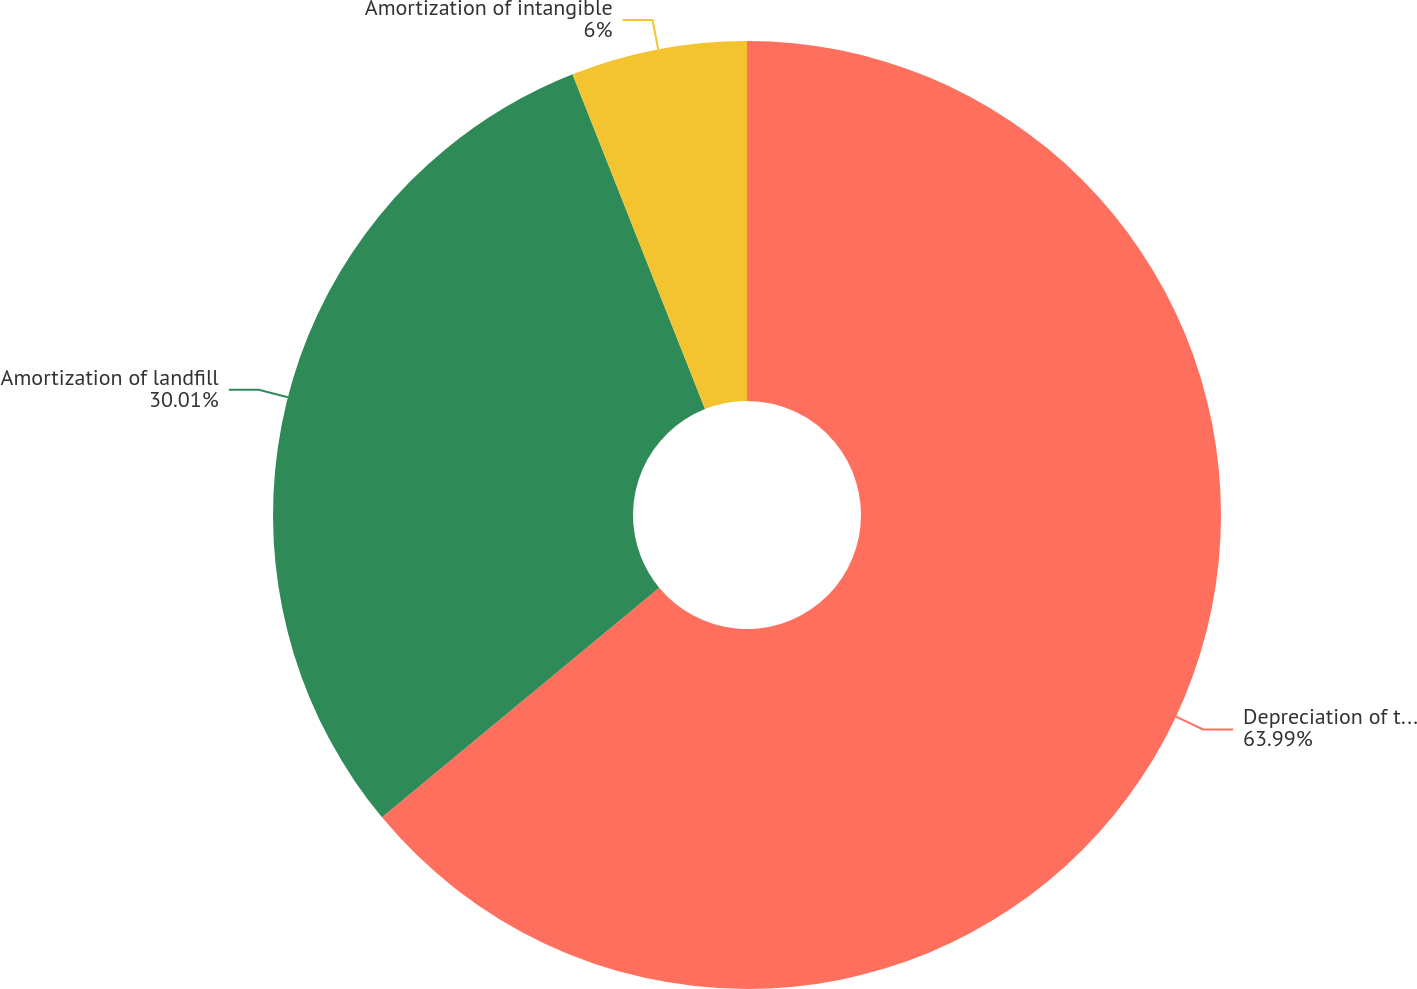Convert chart. <chart><loc_0><loc_0><loc_500><loc_500><pie_chart><fcel>Depreciation of tangible<fcel>Amortization of landfill<fcel>Amortization of intangible<nl><fcel>63.99%<fcel>30.01%<fcel>6.0%<nl></chart> 